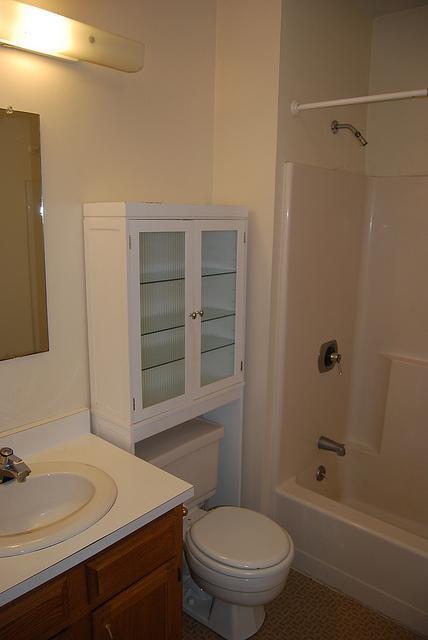How many shelves are in the cabinet with the glass doors?
Give a very brief answer. 4. How many power outlets can be seen?
Give a very brief answer. 0. How many lights are above the mirror?
Give a very brief answer. 1. How many sinks can be seen?
Give a very brief answer. 1. How many buses are there?
Give a very brief answer. 0. 